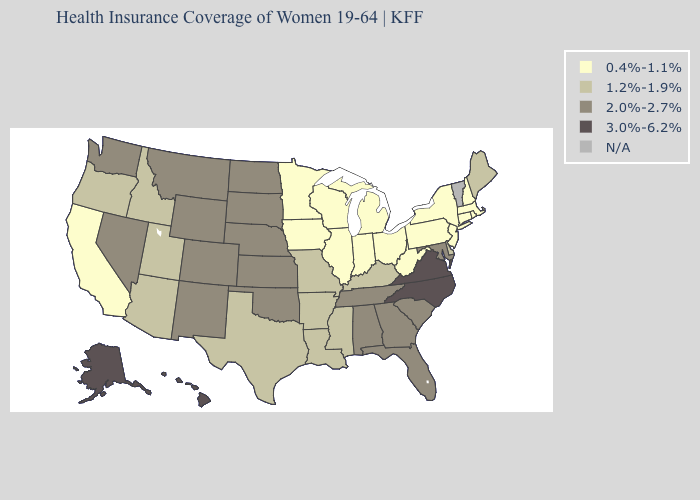Which states have the highest value in the USA?
Short answer required. Alaska, Hawaii, North Carolina, Virginia. What is the lowest value in the MidWest?
Concise answer only. 0.4%-1.1%. What is the lowest value in the USA?
Give a very brief answer. 0.4%-1.1%. Name the states that have a value in the range 2.0%-2.7%?
Quick response, please. Alabama, Colorado, Florida, Georgia, Kansas, Maryland, Montana, Nebraska, Nevada, New Mexico, North Dakota, Oklahoma, South Carolina, South Dakota, Tennessee, Washington, Wyoming. Does Hawaii have the highest value in the USA?
Be succinct. Yes. Does the map have missing data?
Answer briefly. Yes. What is the value of California?
Keep it brief. 0.4%-1.1%. How many symbols are there in the legend?
Write a very short answer. 5. Which states hav the highest value in the MidWest?
Short answer required. Kansas, Nebraska, North Dakota, South Dakota. Which states hav the highest value in the South?
Answer briefly. North Carolina, Virginia. Does North Carolina have the highest value in the USA?
Be succinct. Yes. Among the states that border North Carolina , which have the highest value?
Quick response, please. Virginia. Does California have the lowest value in the West?
Quick response, please. Yes. Name the states that have a value in the range N/A?
Short answer required. Vermont. 